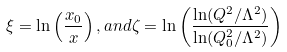<formula> <loc_0><loc_0><loc_500><loc_500>\xi = \ln \left ( \frac { x _ { 0 } } { x } \right ) , a n d \zeta = \ln \left ( \frac { \ln ( Q ^ { 2 } / \Lambda ^ { 2 } ) } { \ln ( Q _ { 0 } ^ { 2 } / \Lambda ^ { 2 } ) } \right )</formula> 